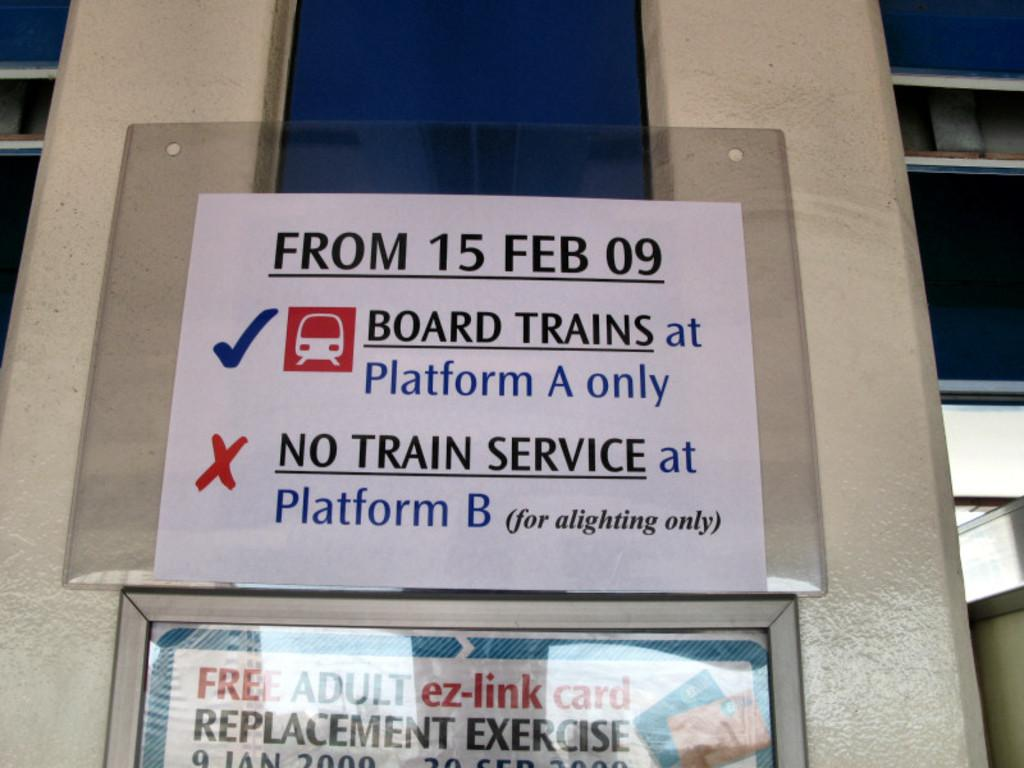What is located in the center of the image? There are posters in the center of the image. How are the posters attached to the wall? The posters are stuck to the wall. What can be seen in the background of the image? There is a building in the background of the image. What is written or depicted on the posters? There is text on the posters. Can you tell me how many potatoes are hidden behind the posters in the image? There are no potatoes present in the image; it only features posters on the wall. Is there a house visible in the image? The image does not show a house; it only includes posters and a building in the background. 